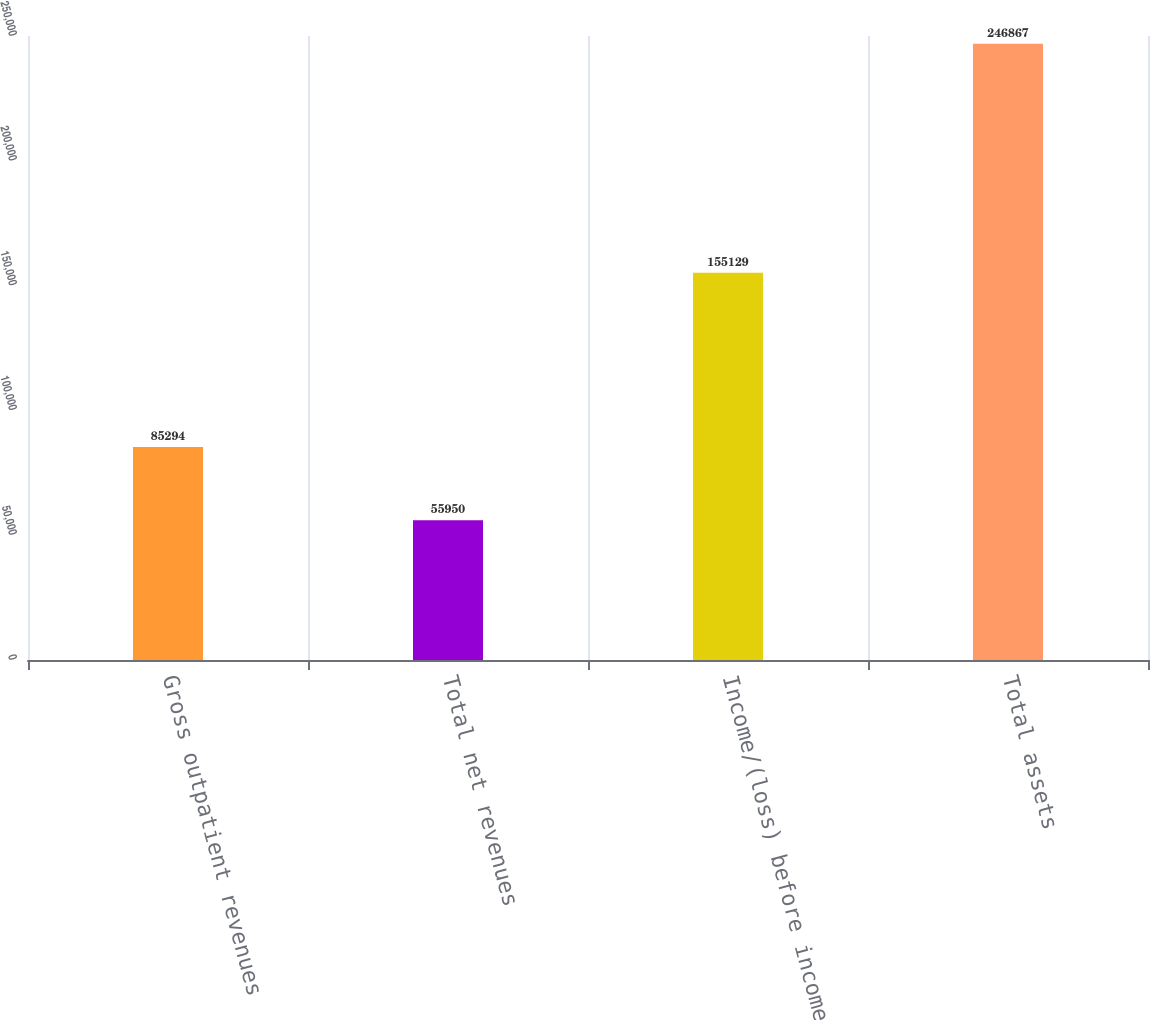<chart> <loc_0><loc_0><loc_500><loc_500><bar_chart><fcel>Gross outpatient revenues<fcel>Total net revenues<fcel>Income/(loss) before income<fcel>Total assets<nl><fcel>85294<fcel>55950<fcel>155129<fcel>246867<nl></chart> 